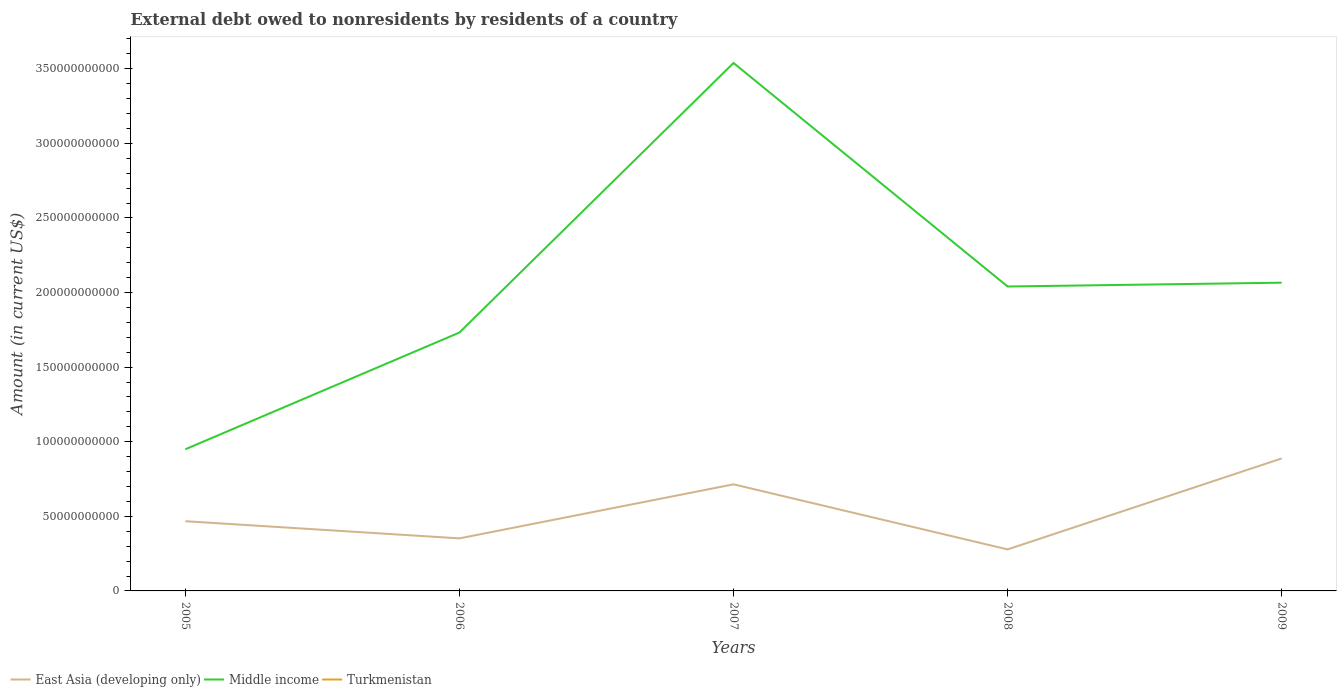How many different coloured lines are there?
Make the answer very short. 2. Does the line corresponding to East Asia (developing only) intersect with the line corresponding to Turkmenistan?
Give a very brief answer. No. Across all years, what is the maximum external debt owed by residents in East Asia (developing only)?
Keep it short and to the point. 2.78e+1. What is the total external debt owed by residents in Middle income in the graph?
Your answer should be very brief. 1.50e+11. What is the difference between the highest and the second highest external debt owed by residents in East Asia (developing only)?
Keep it short and to the point. 6.10e+1. Is the external debt owed by residents in Middle income strictly greater than the external debt owed by residents in Turkmenistan over the years?
Provide a succinct answer. No. How many lines are there?
Ensure brevity in your answer.  2. What is the difference between two consecutive major ticks on the Y-axis?
Offer a very short reply. 5.00e+1. Are the values on the major ticks of Y-axis written in scientific E-notation?
Ensure brevity in your answer.  No. Does the graph contain grids?
Offer a very short reply. No. How many legend labels are there?
Provide a succinct answer. 3. What is the title of the graph?
Your answer should be very brief. External debt owed to nonresidents by residents of a country. Does "Channel Islands" appear as one of the legend labels in the graph?
Offer a terse response. No. What is the label or title of the X-axis?
Give a very brief answer. Years. What is the Amount (in current US$) of East Asia (developing only) in 2005?
Give a very brief answer. 4.67e+1. What is the Amount (in current US$) of Middle income in 2005?
Offer a terse response. 9.50e+1. What is the Amount (in current US$) in Turkmenistan in 2005?
Give a very brief answer. 0. What is the Amount (in current US$) of East Asia (developing only) in 2006?
Your answer should be very brief. 3.52e+1. What is the Amount (in current US$) of Middle income in 2006?
Ensure brevity in your answer.  1.73e+11. What is the Amount (in current US$) in East Asia (developing only) in 2007?
Offer a very short reply. 7.15e+1. What is the Amount (in current US$) in Middle income in 2007?
Your response must be concise. 3.54e+11. What is the Amount (in current US$) of Turkmenistan in 2007?
Provide a short and direct response. 0. What is the Amount (in current US$) in East Asia (developing only) in 2008?
Your answer should be very brief. 2.78e+1. What is the Amount (in current US$) of Middle income in 2008?
Offer a very short reply. 2.04e+11. What is the Amount (in current US$) of East Asia (developing only) in 2009?
Give a very brief answer. 8.88e+1. What is the Amount (in current US$) of Middle income in 2009?
Make the answer very short. 2.07e+11. Across all years, what is the maximum Amount (in current US$) in East Asia (developing only)?
Make the answer very short. 8.88e+1. Across all years, what is the maximum Amount (in current US$) of Middle income?
Your answer should be very brief. 3.54e+11. Across all years, what is the minimum Amount (in current US$) in East Asia (developing only)?
Offer a very short reply. 2.78e+1. Across all years, what is the minimum Amount (in current US$) of Middle income?
Make the answer very short. 9.50e+1. What is the total Amount (in current US$) of East Asia (developing only) in the graph?
Your answer should be very brief. 2.70e+11. What is the total Amount (in current US$) of Middle income in the graph?
Give a very brief answer. 1.03e+12. What is the difference between the Amount (in current US$) in East Asia (developing only) in 2005 and that in 2006?
Give a very brief answer. 1.15e+1. What is the difference between the Amount (in current US$) of Middle income in 2005 and that in 2006?
Your response must be concise. -7.82e+1. What is the difference between the Amount (in current US$) of East Asia (developing only) in 2005 and that in 2007?
Provide a short and direct response. -2.47e+1. What is the difference between the Amount (in current US$) of Middle income in 2005 and that in 2007?
Your response must be concise. -2.59e+11. What is the difference between the Amount (in current US$) in East Asia (developing only) in 2005 and that in 2008?
Keep it short and to the point. 1.89e+1. What is the difference between the Amount (in current US$) in Middle income in 2005 and that in 2008?
Make the answer very short. -1.09e+11. What is the difference between the Amount (in current US$) in East Asia (developing only) in 2005 and that in 2009?
Provide a succinct answer. -4.21e+1. What is the difference between the Amount (in current US$) in Middle income in 2005 and that in 2009?
Provide a short and direct response. -1.12e+11. What is the difference between the Amount (in current US$) in East Asia (developing only) in 2006 and that in 2007?
Keep it short and to the point. -3.62e+1. What is the difference between the Amount (in current US$) in Middle income in 2006 and that in 2007?
Your answer should be very brief. -1.81e+11. What is the difference between the Amount (in current US$) of East Asia (developing only) in 2006 and that in 2008?
Your answer should be very brief. 7.39e+09. What is the difference between the Amount (in current US$) in Middle income in 2006 and that in 2008?
Your response must be concise. -3.09e+1. What is the difference between the Amount (in current US$) in East Asia (developing only) in 2006 and that in 2009?
Offer a very short reply. -5.36e+1. What is the difference between the Amount (in current US$) of Middle income in 2006 and that in 2009?
Offer a terse response. -3.34e+1. What is the difference between the Amount (in current US$) in East Asia (developing only) in 2007 and that in 2008?
Provide a succinct answer. 4.36e+1. What is the difference between the Amount (in current US$) in Middle income in 2007 and that in 2008?
Offer a terse response. 1.50e+11. What is the difference between the Amount (in current US$) of East Asia (developing only) in 2007 and that in 2009?
Give a very brief answer. -1.73e+1. What is the difference between the Amount (in current US$) in Middle income in 2007 and that in 2009?
Ensure brevity in your answer.  1.47e+11. What is the difference between the Amount (in current US$) in East Asia (developing only) in 2008 and that in 2009?
Provide a short and direct response. -6.10e+1. What is the difference between the Amount (in current US$) in Middle income in 2008 and that in 2009?
Your answer should be very brief. -2.55e+09. What is the difference between the Amount (in current US$) in East Asia (developing only) in 2005 and the Amount (in current US$) in Middle income in 2006?
Provide a succinct answer. -1.26e+11. What is the difference between the Amount (in current US$) in East Asia (developing only) in 2005 and the Amount (in current US$) in Middle income in 2007?
Give a very brief answer. -3.07e+11. What is the difference between the Amount (in current US$) in East Asia (developing only) in 2005 and the Amount (in current US$) in Middle income in 2008?
Your response must be concise. -1.57e+11. What is the difference between the Amount (in current US$) of East Asia (developing only) in 2005 and the Amount (in current US$) of Middle income in 2009?
Offer a very short reply. -1.60e+11. What is the difference between the Amount (in current US$) of East Asia (developing only) in 2006 and the Amount (in current US$) of Middle income in 2007?
Ensure brevity in your answer.  -3.19e+11. What is the difference between the Amount (in current US$) in East Asia (developing only) in 2006 and the Amount (in current US$) in Middle income in 2008?
Provide a succinct answer. -1.69e+11. What is the difference between the Amount (in current US$) of East Asia (developing only) in 2006 and the Amount (in current US$) of Middle income in 2009?
Offer a very short reply. -1.71e+11. What is the difference between the Amount (in current US$) of East Asia (developing only) in 2007 and the Amount (in current US$) of Middle income in 2008?
Keep it short and to the point. -1.33e+11. What is the difference between the Amount (in current US$) in East Asia (developing only) in 2007 and the Amount (in current US$) in Middle income in 2009?
Make the answer very short. -1.35e+11. What is the difference between the Amount (in current US$) in East Asia (developing only) in 2008 and the Amount (in current US$) in Middle income in 2009?
Provide a succinct answer. -1.79e+11. What is the average Amount (in current US$) in East Asia (developing only) per year?
Ensure brevity in your answer.  5.40e+1. What is the average Amount (in current US$) of Middle income per year?
Make the answer very short. 2.07e+11. What is the average Amount (in current US$) of Turkmenistan per year?
Give a very brief answer. 0. In the year 2005, what is the difference between the Amount (in current US$) in East Asia (developing only) and Amount (in current US$) in Middle income?
Offer a very short reply. -4.82e+1. In the year 2006, what is the difference between the Amount (in current US$) in East Asia (developing only) and Amount (in current US$) in Middle income?
Ensure brevity in your answer.  -1.38e+11. In the year 2007, what is the difference between the Amount (in current US$) in East Asia (developing only) and Amount (in current US$) in Middle income?
Provide a succinct answer. -2.82e+11. In the year 2008, what is the difference between the Amount (in current US$) in East Asia (developing only) and Amount (in current US$) in Middle income?
Offer a terse response. -1.76e+11. In the year 2009, what is the difference between the Amount (in current US$) in East Asia (developing only) and Amount (in current US$) in Middle income?
Your response must be concise. -1.18e+11. What is the ratio of the Amount (in current US$) in East Asia (developing only) in 2005 to that in 2006?
Give a very brief answer. 1.33. What is the ratio of the Amount (in current US$) in Middle income in 2005 to that in 2006?
Your response must be concise. 0.55. What is the ratio of the Amount (in current US$) in East Asia (developing only) in 2005 to that in 2007?
Your answer should be compact. 0.65. What is the ratio of the Amount (in current US$) of Middle income in 2005 to that in 2007?
Ensure brevity in your answer.  0.27. What is the ratio of the Amount (in current US$) of East Asia (developing only) in 2005 to that in 2008?
Your response must be concise. 1.68. What is the ratio of the Amount (in current US$) of Middle income in 2005 to that in 2008?
Ensure brevity in your answer.  0.47. What is the ratio of the Amount (in current US$) of East Asia (developing only) in 2005 to that in 2009?
Your answer should be very brief. 0.53. What is the ratio of the Amount (in current US$) in Middle income in 2005 to that in 2009?
Your answer should be compact. 0.46. What is the ratio of the Amount (in current US$) in East Asia (developing only) in 2006 to that in 2007?
Provide a succinct answer. 0.49. What is the ratio of the Amount (in current US$) of Middle income in 2006 to that in 2007?
Give a very brief answer. 0.49. What is the ratio of the Amount (in current US$) in East Asia (developing only) in 2006 to that in 2008?
Make the answer very short. 1.27. What is the ratio of the Amount (in current US$) in Middle income in 2006 to that in 2008?
Your answer should be compact. 0.85. What is the ratio of the Amount (in current US$) in East Asia (developing only) in 2006 to that in 2009?
Make the answer very short. 0.4. What is the ratio of the Amount (in current US$) of Middle income in 2006 to that in 2009?
Provide a short and direct response. 0.84. What is the ratio of the Amount (in current US$) of East Asia (developing only) in 2007 to that in 2008?
Your answer should be compact. 2.57. What is the ratio of the Amount (in current US$) of Middle income in 2007 to that in 2008?
Offer a terse response. 1.73. What is the ratio of the Amount (in current US$) of East Asia (developing only) in 2007 to that in 2009?
Ensure brevity in your answer.  0.8. What is the ratio of the Amount (in current US$) of Middle income in 2007 to that in 2009?
Keep it short and to the point. 1.71. What is the ratio of the Amount (in current US$) of East Asia (developing only) in 2008 to that in 2009?
Keep it short and to the point. 0.31. What is the ratio of the Amount (in current US$) in Middle income in 2008 to that in 2009?
Your answer should be very brief. 0.99. What is the difference between the highest and the second highest Amount (in current US$) of East Asia (developing only)?
Keep it short and to the point. 1.73e+1. What is the difference between the highest and the second highest Amount (in current US$) of Middle income?
Provide a succinct answer. 1.47e+11. What is the difference between the highest and the lowest Amount (in current US$) in East Asia (developing only)?
Offer a very short reply. 6.10e+1. What is the difference between the highest and the lowest Amount (in current US$) of Middle income?
Offer a very short reply. 2.59e+11. 